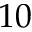<formula> <loc_0><loc_0><loc_500><loc_500>1 0</formula> 